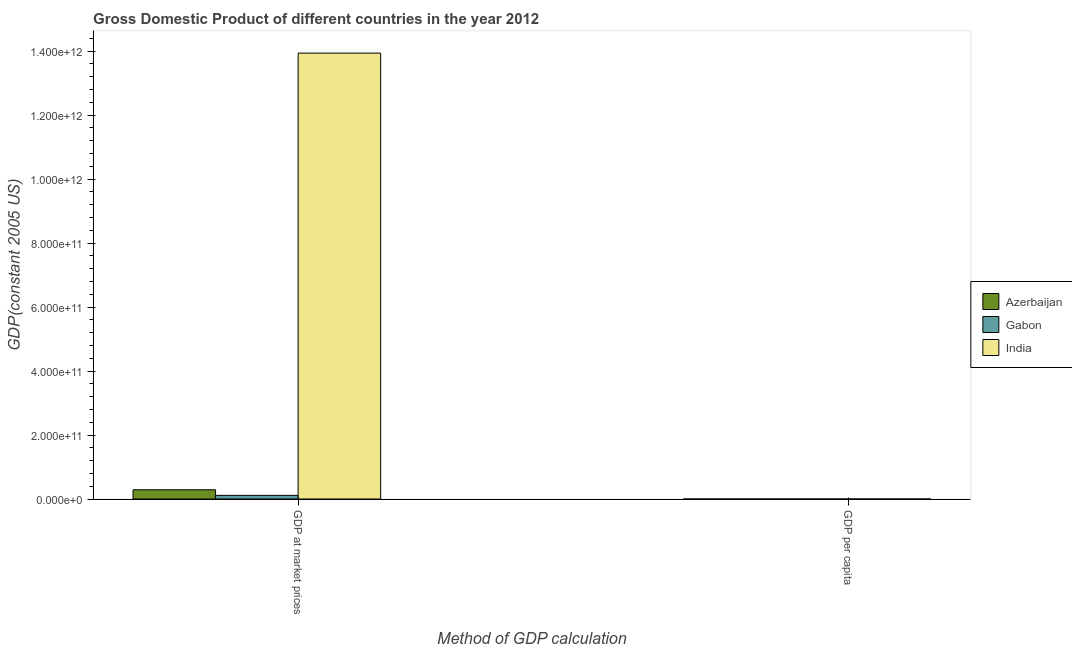How many different coloured bars are there?
Your answer should be compact. 3. How many groups of bars are there?
Make the answer very short. 2. Are the number of bars on each tick of the X-axis equal?
Offer a terse response. Yes. How many bars are there on the 1st tick from the left?
Give a very brief answer. 3. How many bars are there on the 1st tick from the right?
Provide a succinct answer. 3. What is the label of the 2nd group of bars from the left?
Your answer should be very brief. GDP per capita. What is the gdp at market prices in India?
Offer a terse response. 1.39e+12. Across all countries, what is the maximum gdp at market prices?
Your answer should be very brief. 1.39e+12. Across all countries, what is the minimum gdp per capita?
Provide a short and direct response. 1102.91. In which country was the gdp per capita maximum?
Give a very brief answer. Gabon. In which country was the gdp at market prices minimum?
Your answer should be compact. Gabon. What is the total gdp at market prices in the graph?
Provide a short and direct response. 1.43e+12. What is the difference between the gdp per capita in Gabon and that in Azerbaijan?
Your response must be concise. 3975.51. What is the difference between the gdp per capita in Gabon and the gdp at market prices in Azerbaijan?
Keep it short and to the point. -2.90e+1. What is the average gdp per capita per country?
Your answer should be compact. 3769.18. What is the difference between the gdp at market prices and gdp per capita in Azerbaijan?
Provide a short and direct response. 2.90e+1. What is the ratio of the gdp at market prices in Gabon to that in India?
Your answer should be compact. 0.01. What does the 2nd bar from the left in GDP at market prices represents?
Make the answer very short. Gabon. What does the 2nd bar from the right in GDP per capita represents?
Your answer should be very brief. Gabon. How many bars are there?
Offer a terse response. 6. Are all the bars in the graph horizontal?
Provide a succinct answer. No. What is the difference between two consecutive major ticks on the Y-axis?
Keep it short and to the point. 2.00e+11. Does the graph contain any zero values?
Provide a succinct answer. No. Does the graph contain grids?
Provide a short and direct response. No. How are the legend labels stacked?
Provide a short and direct response. Vertical. What is the title of the graph?
Your answer should be very brief. Gross Domestic Product of different countries in the year 2012. Does "Burkina Faso" appear as one of the legend labels in the graph?
Offer a terse response. No. What is the label or title of the X-axis?
Your answer should be compact. Method of GDP calculation. What is the label or title of the Y-axis?
Your answer should be very brief. GDP(constant 2005 US). What is the GDP(constant 2005 US) of Azerbaijan in GDP at market prices?
Your answer should be very brief. 2.90e+1. What is the GDP(constant 2005 US) of Gabon in GDP at market prices?
Give a very brief answer. 1.14e+1. What is the GDP(constant 2005 US) of India in GDP at market prices?
Provide a short and direct response. 1.39e+12. What is the GDP(constant 2005 US) in Azerbaijan in GDP per capita?
Provide a succinct answer. 3114.56. What is the GDP(constant 2005 US) in Gabon in GDP per capita?
Your answer should be compact. 7090.07. What is the GDP(constant 2005 US) of India in GDP per capita?
Your answer should be very brief. 1102.91. Across all Method of GDP calculation, what is the maximum GDP(constant 2005 US) of Azerbaijan?
Make the answer very short. 2.90e+1. Across all Method of GDP calculation, what is the maximum GDP(constant 2005 US) in Gabon?
Provide a succinct answer. 1.14e+1. Across all Method of GDP calculation, what is the maximum GDP(constant 2005 US) in India?
Keep it short and to the point. 1.39e+12. Across all Method of GDP calculation, what is the minimum GDP(constant 2005 US) of Azerbaijan?
Your answer should be very brief. 3114.56. Across all Method of GDP calculation, what is the minimum GDP(constant 2005 US) in Gabon?
Your answer should be compact. 7090.07. Across all Method of GDP calculation, what is the minimum GDP(constant 2005 US) in India?
Give a very brief answer. 1102.91. What is the total GDP(constant 2005 US) in Azerbaijan in the graph?
Provide a short and direct response. 2.90e+1. What is the total GDP(constant 2005 US) in Gabon in the graph?
Keep it short and to the point. 1.14e+1. What is the total GDP(constant 2005 US) in India in the graph?
Your answer should be very brief. 1.39e+12. What is the difference between the GDP(constant 2005 US) in Azerbaijan in GDP at market prices and that in GDP per capita?
Give a very brief answer. 2.90e+1. What is the difference between the GDP(constant 2005 US) of Gabon in GDP at market prices and that in GDP per capita?
Your response must be concise. 1.14e+1. What is the difference between the GDP(constant 2005 US) of India in GDP at market prices and that in GDP per capita?
Offer a terse response. 1.39e+12. What is the difference between the GDP(constant 2005 US) of Azerbaijan in GDP at market prices and the GDP(constant 2005 US) of Gabon in GDP per capita?
Give a very brief answer. 2.90e+1. What is the difference between the GDP(constant 2005 US) of Azerbaijan in GDP at market prices and the GDP(constant 2005 US) of India in GDP per capita?
Provide a short and direct response. 2.90e+1. What is the difference between the GDP(constant 2005 US) of Gabon in GDP at market prices and the GDP(constant 2005 US) of India in GDP per capita?
Give a very brief answer. 1.14e+1. What is the average GDP(constant 2005 US) of Azerbaijan per Method of GDP calculation?
Provide a succinct answer. 1.45e+1. What is the average GDP(constant 2005 US) of Gabon per Method of GDP calculation?
Keep it short and to the point. 5.72e+09. What is the average GDP(constant 2005 US) of India per Method of GDP calculation?
Offer a terse response. 6.97e+11. What is the difference between the GDP(constant 2005 US) of Azerbaijan and GDP(constant 2005 US) of Gabon in GDP at market prices?
Make the answer very short. 1.75e+1. What is the difference between the GDP(constant 2005 US) in Azerbaijan and GDP(constant 2005 US) in India in GDP at market prices?
Keep it short and to the point. -1.36e+12. What is the difference between the GDP(constant 2005 US) of Gabon and GDP(constant 2005 US) of India in GDP at market prices?
Provide a succinct answer. -1.38e+12. What is the difference between the GDP(constant 2005 US) in Azerbaijan and GDP(constant 2005 US) in Gabon in GDP per capita?
Offer a very short reply. -3975.51. What is the difference between the GDP(constant 2005 US) of Azerbaijan and GDP(constant 2005 US) of India in GDP per capita?
Keep it short and to the point. 2011.65. What is the difference between the GDP(constant 2005 US) in Gabon and GDP(constant 2005 US) in India in GDP per capita?
Offer a terse response. 5987.16. What is the ratio of the GDP(constant 2005 US) in Azerbaijan in GDP at market prices to that in GDP per capita?
Offer a terse response. 9.30e+06. What is the ratio of the GDP(constant 2005 US) in Gabon in GDP at market prices to that in GDP per capita?
Keep it short and to the point. 1.61e+06. What is the ratio of the GDP(constant 2005 US) in India in GDP at market prices to that in GDP per capita?
Provide a short and direct response. 1.26e+09. What is the difference between the highest and the second highest GDP(constant 2005 US) in Azerbaijan?
Your answer should be compact. 2.90e+1. What is the difference between the highest and the second highest GDP(constant 2005 US) in Gabon?
Provide a succinct answer. 1.14e+1. What is the difference between the highest and the second highest GDP(constant 2005 US) in India?
Make the answer very short. 1.39e+12. What is the difference between the highest and the lowest GDP(constant 2005 US) of Azerbaijan?
Your answer should be very brief. 2.90e+1. What is the difference between the highest and the lowest GDP(constant 2005 US) in Gabon?
Your answer should be compact. 1.14e+1. What is the difference between the highest and the lowest GDP(constant 2005 US) in India?
Provide a succinct answer. 1.39e+12. 